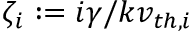Convert formula to latex. <formula><loc_0><loc_0><loc_500><loc_500>\zeta _ { i } \colon = i \gamma / k v _ { t h , i }</formula> 